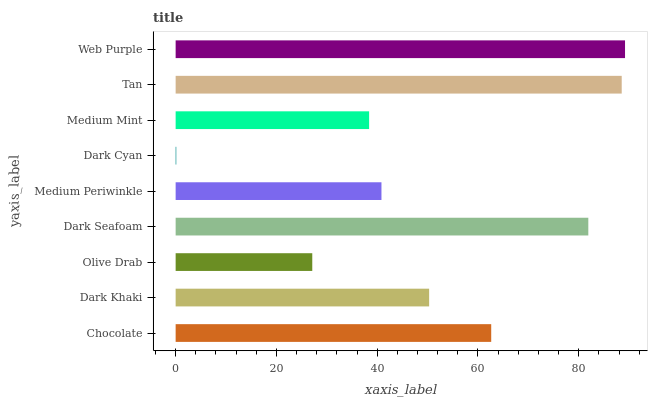Is Dark Cyan the minimum?
Answer yes or no. Yes. Is Web Purple the maximum?
Answer yes or no. Yes. Is Dark Khaki the minimum?
Answer yes or no. No. Is Dark Khaki the maximum?
Answer yes or no. No. Is Chocolate greater than Dark Khaki?
Answer yes or no. Yes. Is Dark Khaki less than Chocolate?
Answer yes or no. Yes. Is Dark Khaki greater than Chocolate?
Answer yes or no. No. Is Chocolate less than Dark Khaki?
Answer yes or no. No. Is Dark Khaki the high median?
Answer yes or no. Yes. Is Dark Khaki the low median?
Answer yes or no. Yes. Is Dark Cyan the high median?
Answer yes or no. No. Is Medium Mint the low median?
Answer yes or no. No. 